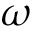<formula> <loc_0><loc_0><loc_500><loc_500>\omega</formula> 